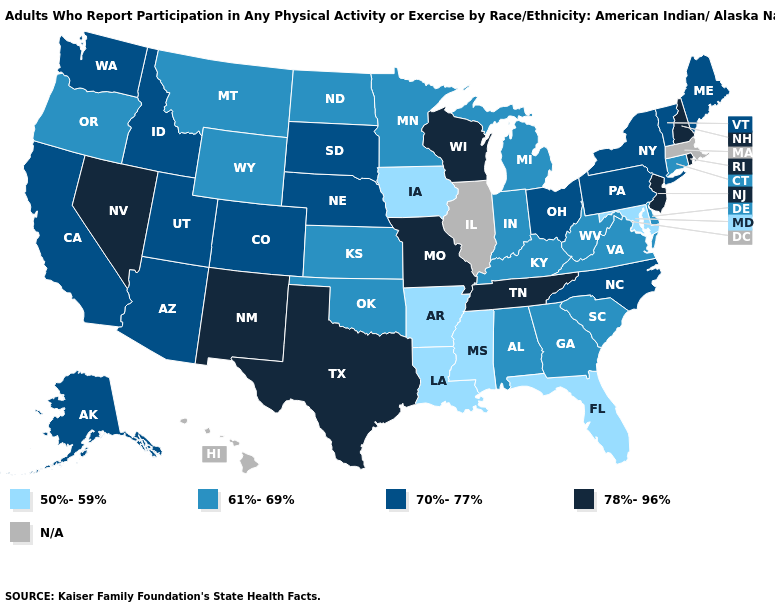Which states have the lowest value in the USA?
Quick response, please. Arkansas, Florida, Iowa, Louisiana, Maryland, Mississippi. Name the states that have a value in the range 61%-69%?
Short answer required. Alabama, Connecticut, Delaware, Georgia, Indiana, Kansas, Kentucky, Michigan, Minnesota, Montana, North Dakota, Oklahoma, Oregon, South Carolina, Virginia, West Virginia, Wyoming. Name the states that have a value in the range N/A?
Write a very short answer. Hawaii, Illinois, Massachusetts. What is the lowest value in states that border Missouri?
Short answer required. 50%-59%. Name the states that have a value in the range 78%-96%?
Keep it brief. Missouri, Nevada, New Hampshire, New Jersey, New Mexico, Rhode Island, Tennessee, Texas, Wisconsin. What is the value of Missouri?
Concise answer only. 78%-96%. Among the states that border Kentucky , does Missouri have the lowest value?
Keep it brief. No. What is the lowest value in the USA?
Write a very short answer. 50%-59%. Does Florida have the lowest value in the South?
Concise answer only. Yes. Name the states that have a value in the range 78%-96%?
Give a very brief answer. Missouri, Nevada, New Hampshire, New Jersey, New Mexico, Rhode Island, Tennessee, Texas, Wisconsin. Does the map have missing data?
Concise answer only. Yes. Is the legend a continuous bar?
Keep it brief. No. Name the states that have a value in the range 61%-69%?
Keep it brief. Alabama, Connecticut, Delaware, Georgia, Indiana, Kansas, Kentucky, Michigan, Minnesota, Montana, North Dakota, Oklahoma, Oregon, South Carolina, Virginia, West Virginia, Wyoming. 